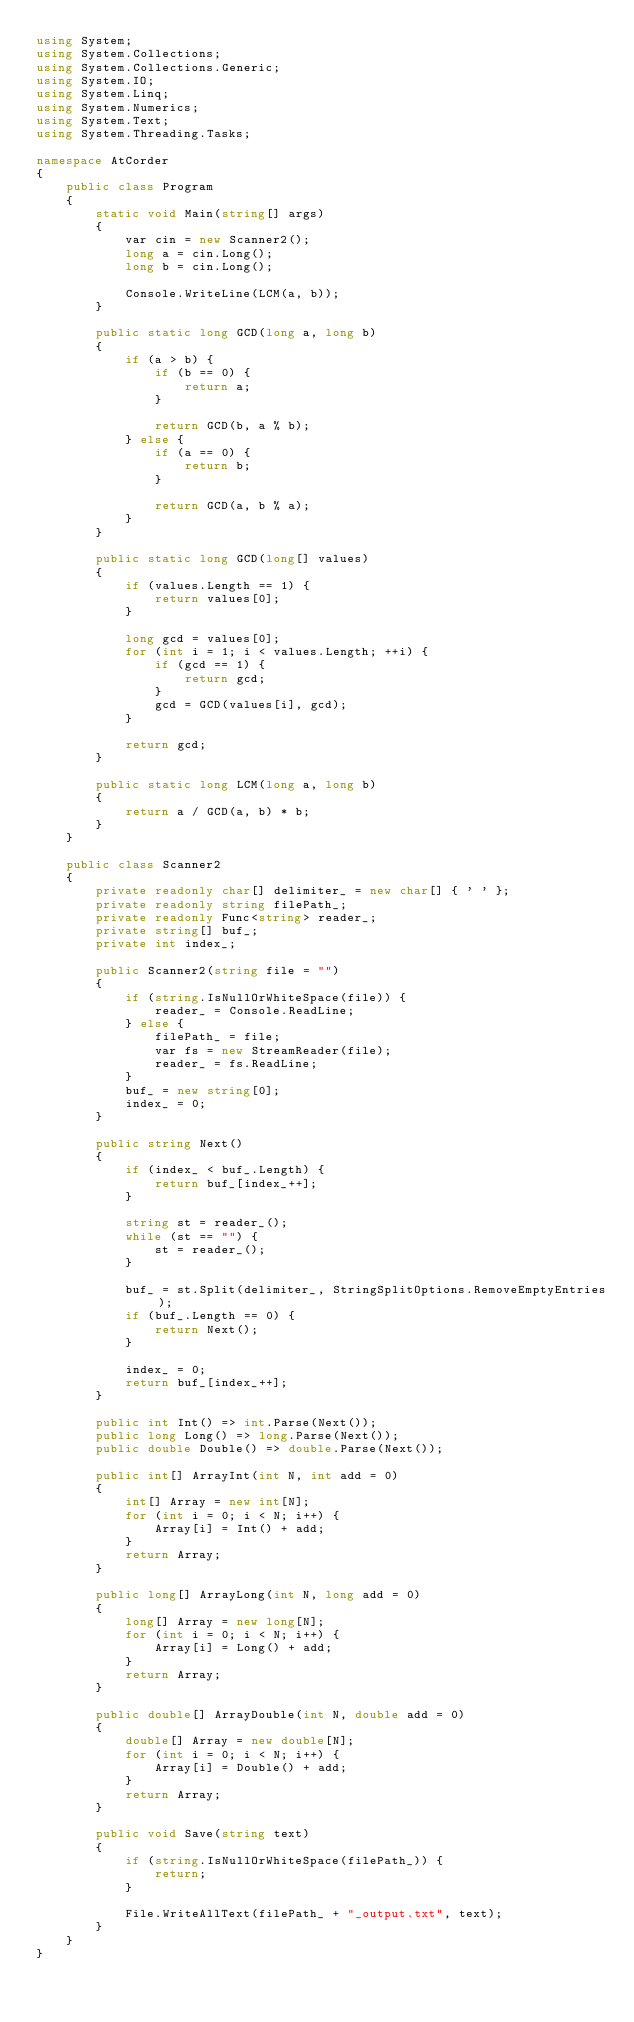Convert code to text. <code><loc_0><loc_0><loc_500><loc_500><_C#_>using System;
using System.Collections;
using System.Collections.Generic;
using System.IO;
using System.Linq;
using System.Numerics;
using System.Text;
using System.Threading.Tasks;

namespace AtCorder
{
	public class Program
	{
		static void Main(string[] args)
		{
			var cin = new Scanner2();
			long a = cin.Long();
			long b = cin.Long();

			Console.WriteLine(LCM(a, b));
		}

		public static long GCD(long a, long b)
		{
			if (a > b) {
				if (b == 0) {
					return a;
				}

				return GCD(b, a % b);
			} else {
				if (a == 0) {
					return b;
				}

				return GCD(a, b % a);
			}
		}

		public static long GCD(long[] values)
		{
			if (values.Length == 1) {
				return values[0];
			}

			long gcd = values[0];
			for (int i = 1; i < values.Length; ++i) {
				if (gcd == 1) {
					return gcd;
				}
				gcd = GCD(values[i], gcd);
			}

			return gcd;
		}

		public static long LCM(long a, long b)
		{
			return a / GCD(a, b) * b;
		}
	}

	public class Scanner2
	{
		private readonly char[] delimiter_ = new char[] { ' ' };
		private readonly string filePath_;
		private readonly Func<string> reader_;
		private string[] buf_;
		private int index_;

		public Scanner2(string file = "")
		{
			if (string.IsNullOrWhiteSpace(file)) {
				reader_ = Console.ReadLine;
			} else {
				filePath_ = file;
				var fs = new StreamReader(file);
				reader_ = fs.ReadLine;
			}
			buf_ = new string[0];
			index_ = 0;
		}

		public string Next()
		{
			if (index_ < buf_.Length) {
				return buf_[index_++];
			}

			string st = reader_();
			while (st == "") {
				st = reader_();
			}

			buf_ = st.Split(delimiter_, StringSplitOptions.RemoveEmptyEntries);
			if (buf_.Length == 0) {
				return Next();
			}

			index_ = 0;
			return buf_[index_++];
		}

		public int Int() => int.Parse(Next());
		public long Long() => long.Parse(Next());
		public double Double() => double.Parse(Next());

		public int[] ArrayInt(int N, int add = 0)
		{
			int[] Array = new int[N];
			for (int i = 0; i < N; i++) {
				Array[i] = Int() + add;
			}
			return Array;
		}

		public long[] ArrayLong(int N, long add = 0)
		{
			long[] Array = new long[N];
			for (int i = 0; i < N; i++) {
				Array[i] = Long() + add;
			}
			return Array;
		}

		public double[] ArrayDouble(int N, double add = 0)
		{
			double[] Array = new double[N];
			for (int i = 0; i < N; i++) {
				Array[i] = Double() + add;
			}
			return Array;
		}

		public void Save(string text)
		{
			if (string.IsNullOrWhiteSpace(filePath_)) {
				return;
			}

			File.WriteAllText(filePath_ + "_output.txt", text);
		}
	}
}</code> 